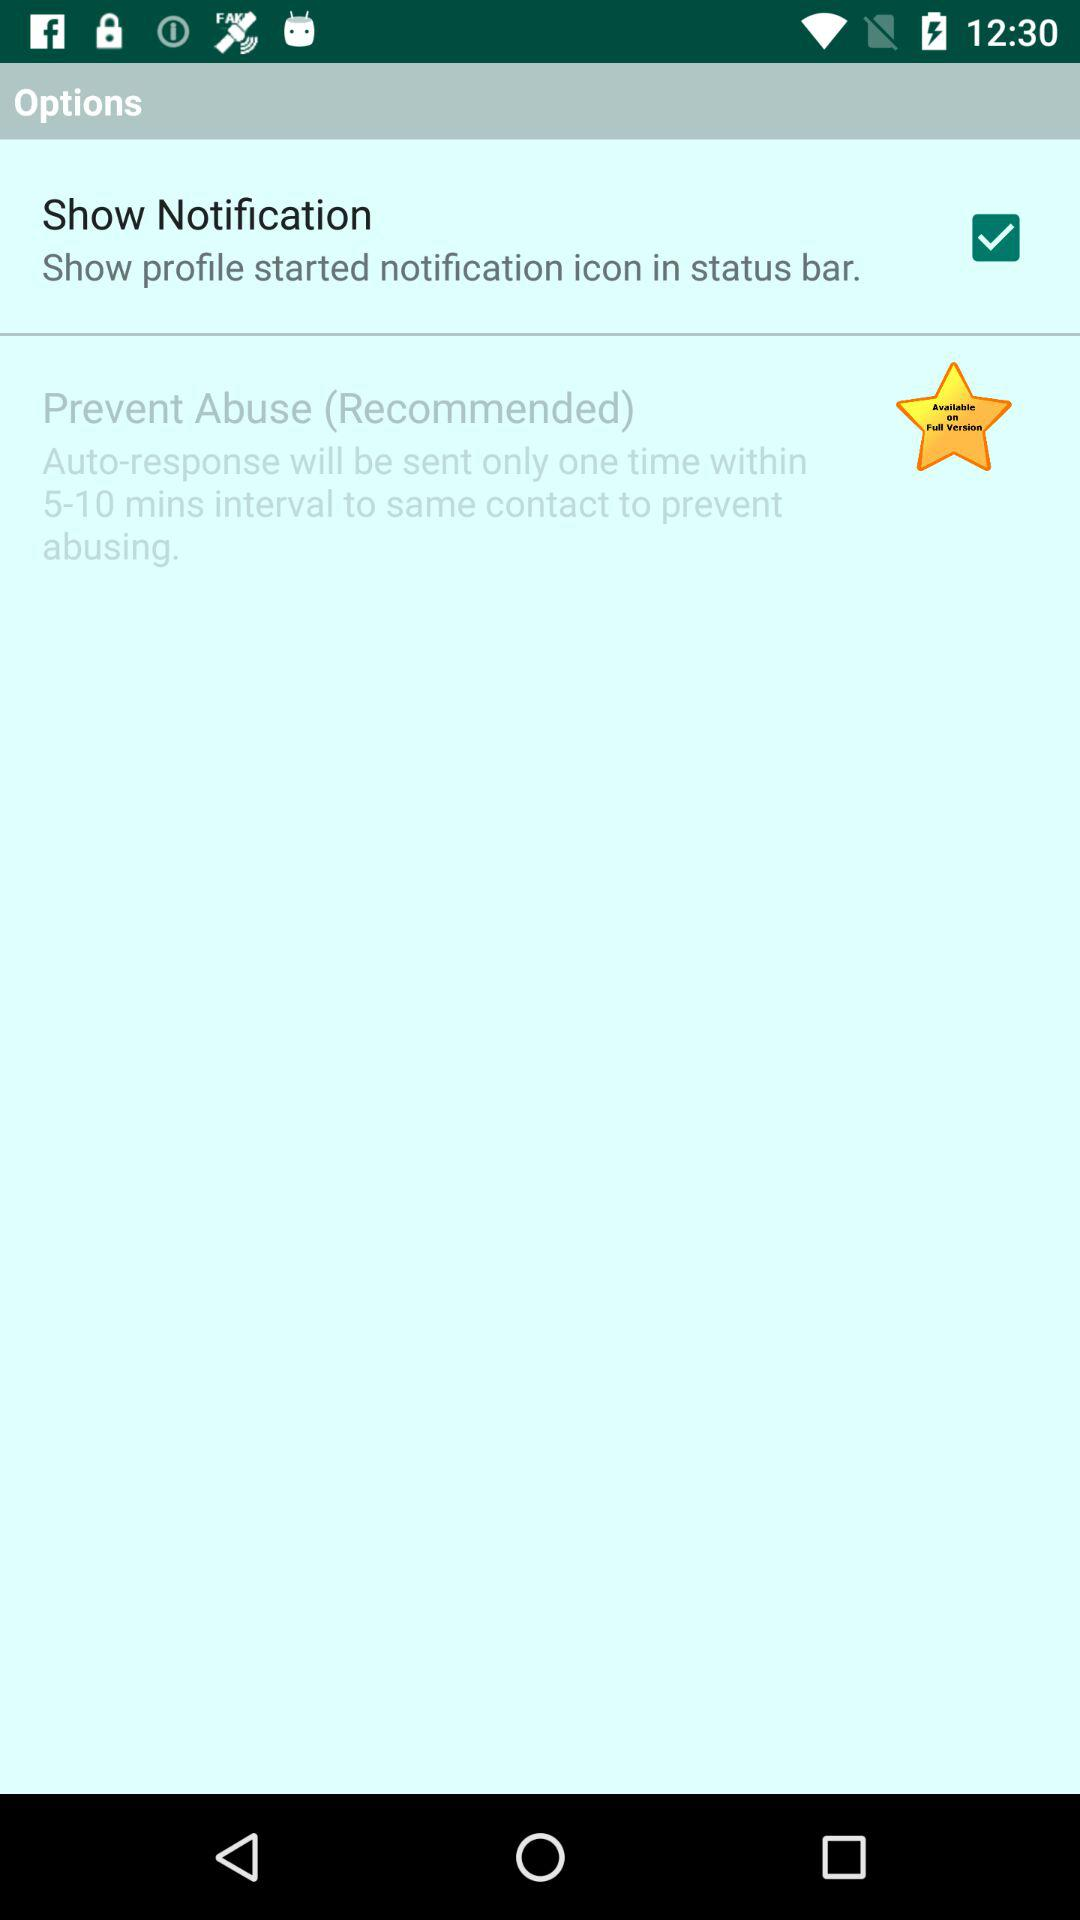How many times will the auto-response be sent? The auto-response will be sent only once. 